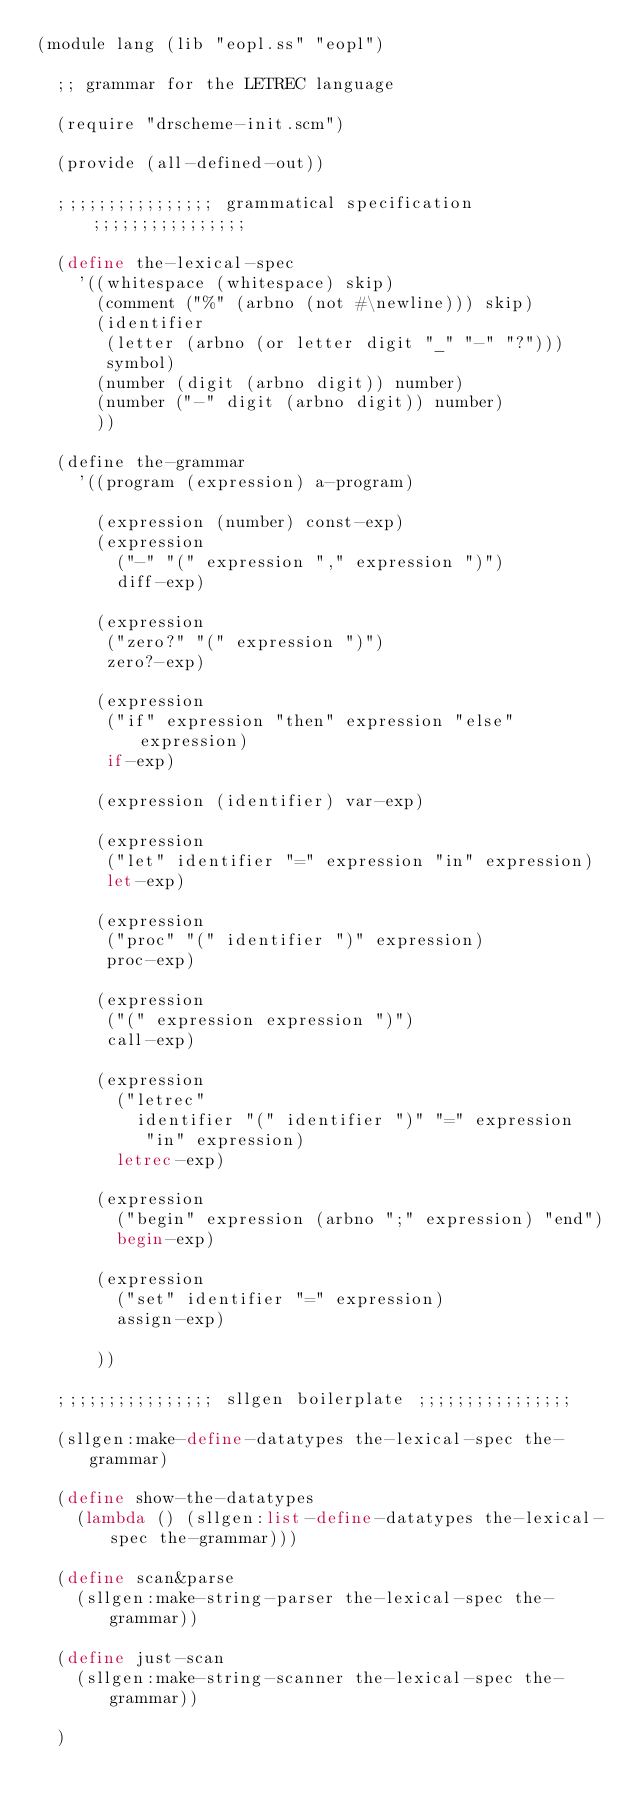<code> <loc_0><loc_0><loc_500><loc_500><_Scheme_>(module lang (lib "eopl.ss" "eopl")                

  ;; grammar for the LETREC language

  (require "drscheme-init.scm")
  
  (provide (all-defined-out))

  ;;;;;;;;;;;;;;;; grammatical specification ;;;;;;;;;;;;;;;;
  
  (define the-lexical-spec
    '((whitespace (whitespace) skip)
      (comment ("%" (arbno (not #\newline))) skip)
      (identifier
       (letter (arbno (or letter digit "_" "-" "?")))
       symbol)
      (number (digit (arbno digit)) number)
      (number ("-" digit (arbno digit)) number)
      ))
  
  (define the-grammar
    '((program (expression) a-program)

      (expression (number) const-exp)
      (expression
        ("-" "(" expression "," expression ")")
        diff-exp)
      
      (expression
       ("zero?" "(" expression ")")
       zero?-exp)

      (expression
       ("if" expression "then" expression "else" expression)
       if-exp)

      (expression (identifier) var-exp)

      (expression
       ("let" identifier "=" expression "in" expression)
       let-exp)   

      (expression
       ("proc" "(" identifier ")" expression)
       proc-exp)

      (expression
       ("(" expression expression ")")
       call-exp)

      (expression
        ("letrec"
          identifier "(" identifier ")" "=" expression
           "in" expression)
        letrec-exp)

      (expression
        ("begin" expression (arbno ";" expression) "end")
        begin-exp)

      (expression
        ("set" identifier "=" expression)
        assign-exp)
      
      ))
  
  ;;;;;;;;;;;;;;;; sllgen boilerplate ;;;;;;;;;;;;;;;;
  
  (sllgen:make-define-datatypes the-lexical-spec the-grammar)
  
  (define show-the-datatypes
    (lambda () (sllgen:list-define-datatypes the-lexical-spec the-grammar)))
  
  (define scan&parse
    (sllgen:make-string-parser the-lexical-spec the-grammar))
  
  (define just-scan
    (sllgen:make-string-scanner the-lexical-spec the-grammar))
  
  )
</code> 